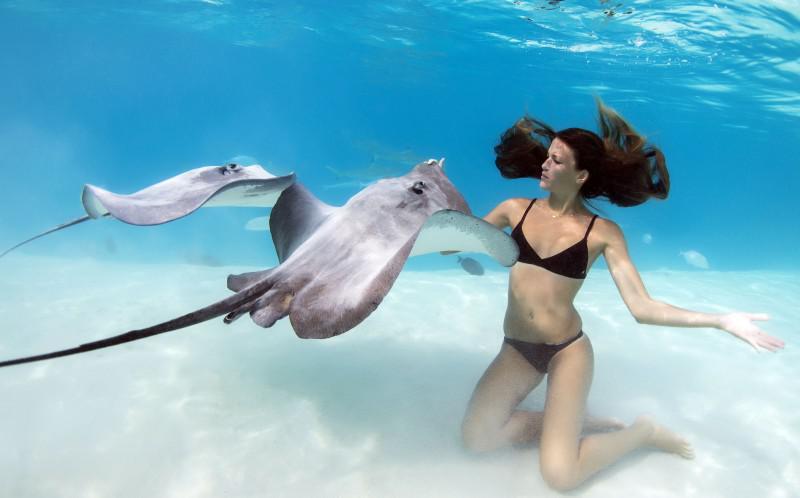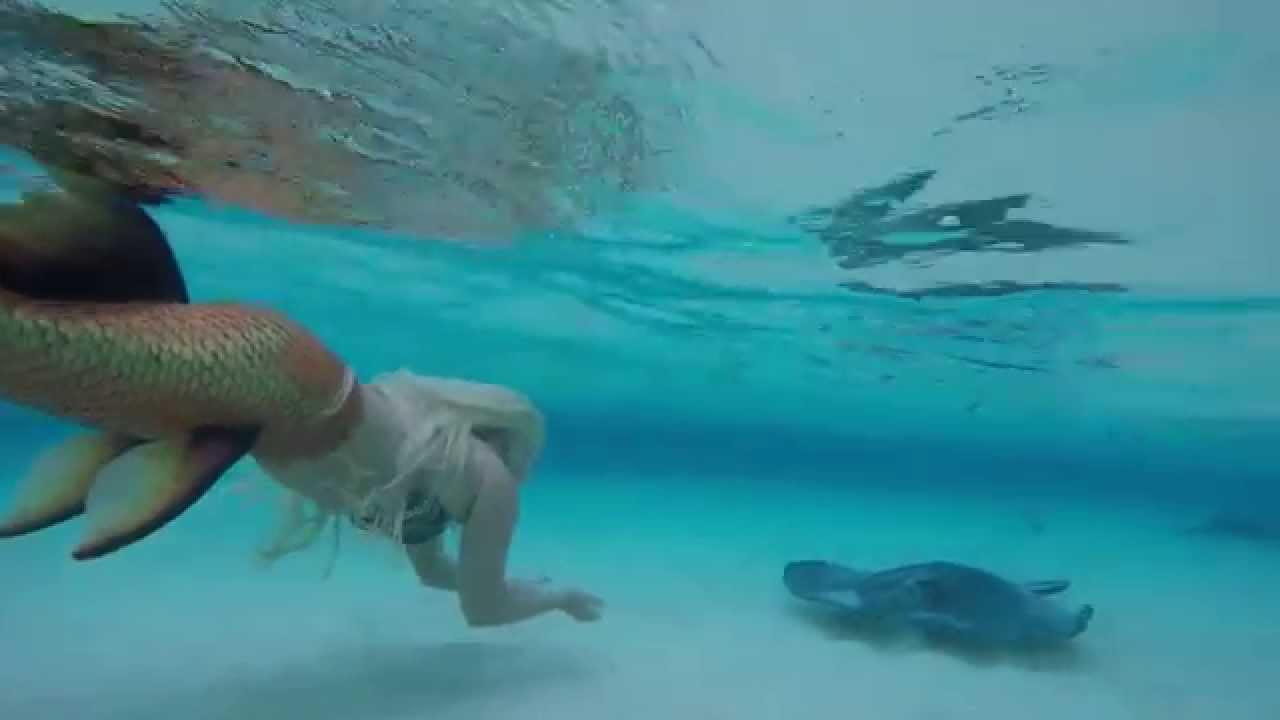The first image is the image on the left, the second image is the image on the right. Analyze the images presented: Is the assertion "There are less than five fish visible." valid? Answer yes or no. Yes. 